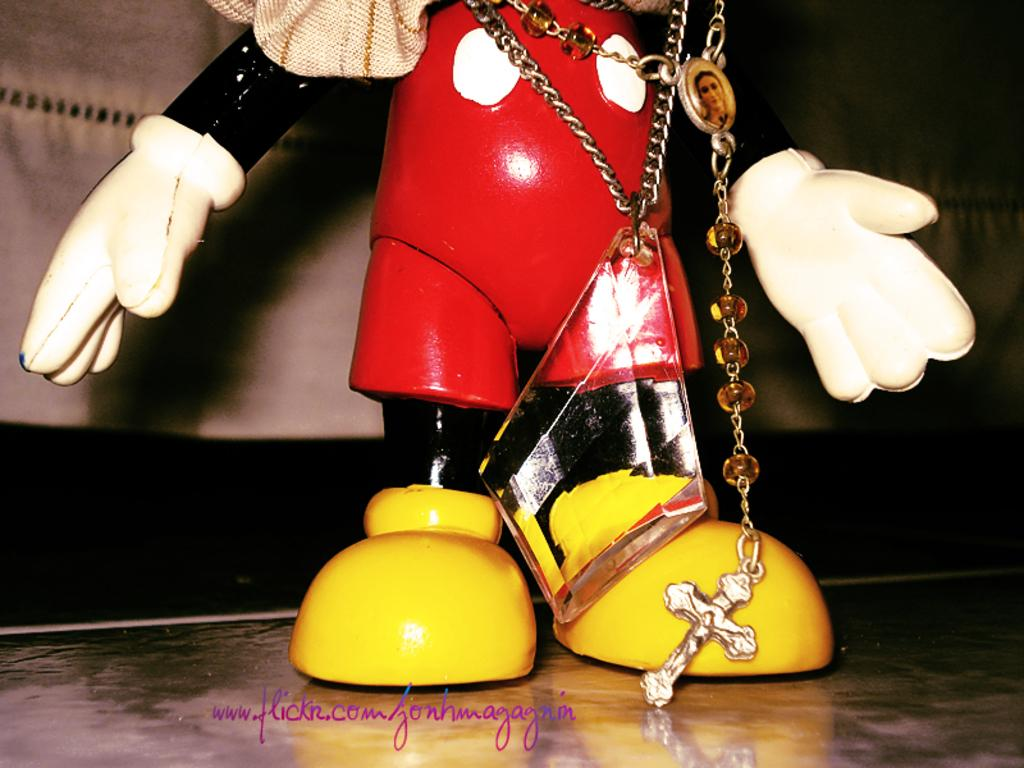What is the main object in the image? There is a toy in the image. Can you describe any other objects or features in the image? There are other unspecified things in the image. Is there any text or marking on the image? Yes, there is a watermark on the image. How would you describe the overall appearance of the image? The background of the image is dark. What type of car is visible in the image? There is no car present in the image. How old is the daughter in the image? There is no daughter present in the image. 